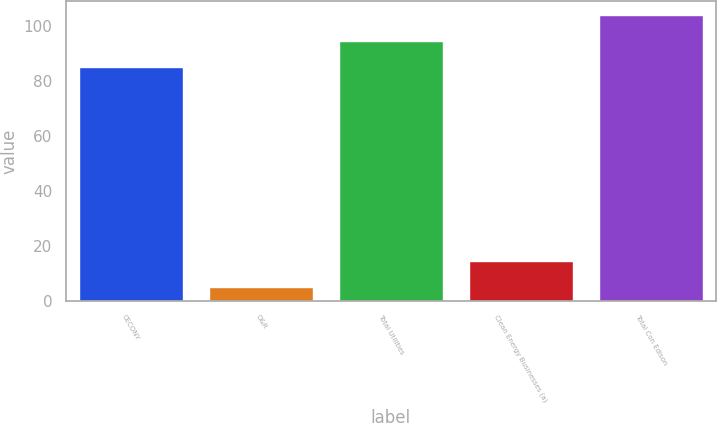Convert chart. <chart><loc_0><loc_0><loc_500><loc_500><bar_chart><fcel>CECONY<fcel>O&R<fcel>Total Utilities<fcel>Clean Energy Businesses (a)<fcel>Total Con Edison<nl><fcel>85<fcel>5<fcel>94.5<fcel>14.5<fcel>104<nl></chart> 